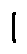Convert formula to latex. <formula><loc_0><loc_0><loc_500><loc_500>1</formula> 